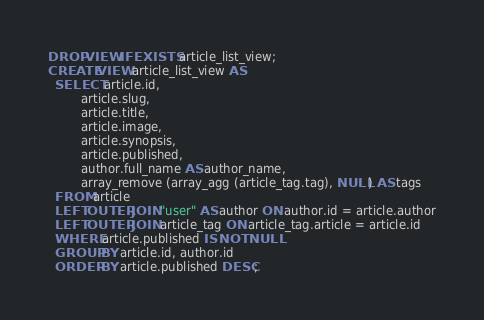<code> <loc_0><loc_0><loc_500><loc_500><_SQL_>DROP VIEW IF EXISTS article_list_view;
CREATE VIEW article_list_view AS
  SELECT article.id,
         article.slug,
         article.title,
         article.image,
         article.synopsis,
         article.published,
         author.full_name AS author_name,
         array_remove (array_agg (article_tag.tag), NULL) AS tags
  FROM article
  LEFT OUTER JOIN "user" AS author ON author.id = article.author
  LEFT OUTER JOIN article_tag ON article_tag.article = article.id
  WHERE article.published IS NOT NULL
  GROUP BY article.id, author.id
  ORDER BY article.published DESC;
</code> 